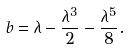<formula> <loc_0><loc_0><loc_500><loc_500>b = \lambda - \frac { \lambda ^ { 3 } } { 2 } - \frac { \lambda ^ { 5 } } { 8 } .</formula> 